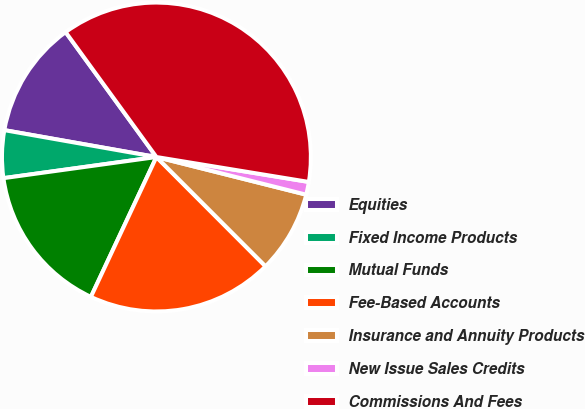<chart> <loc_0><loc_0><loc_500><loc_500><pie_chart><fcel>Equities<fcel>Fixed Income Products<fcel>Mutual Funds<fcel>Fee-Based Accounts<fcel>Insurance and Annuity Products<fcel>New Issue Sales Credits<fcel>Commissions And Fees<nl><fcel>12.21%<fcel>4.97%<fcel>15.84%<fcel>19.46%<fcel>8.59%<fcel>1.34%<fcel>37.58%<nl></chart> 